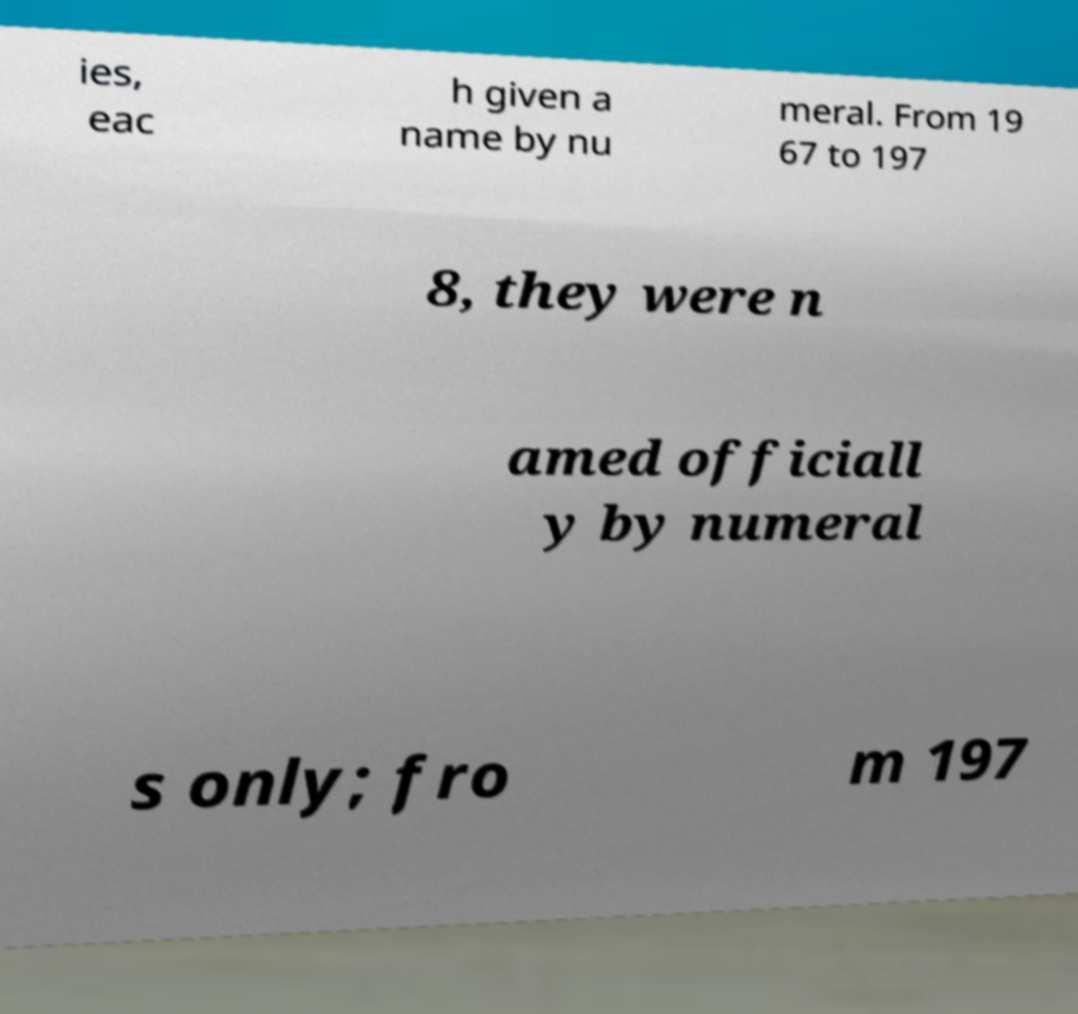I need the written content from this picture converted into text. Can you do that? ies, eac h given a name by nu meral. From 19 67 to 197 8, they were n amed officiall y by numeral s only; fro m 197 